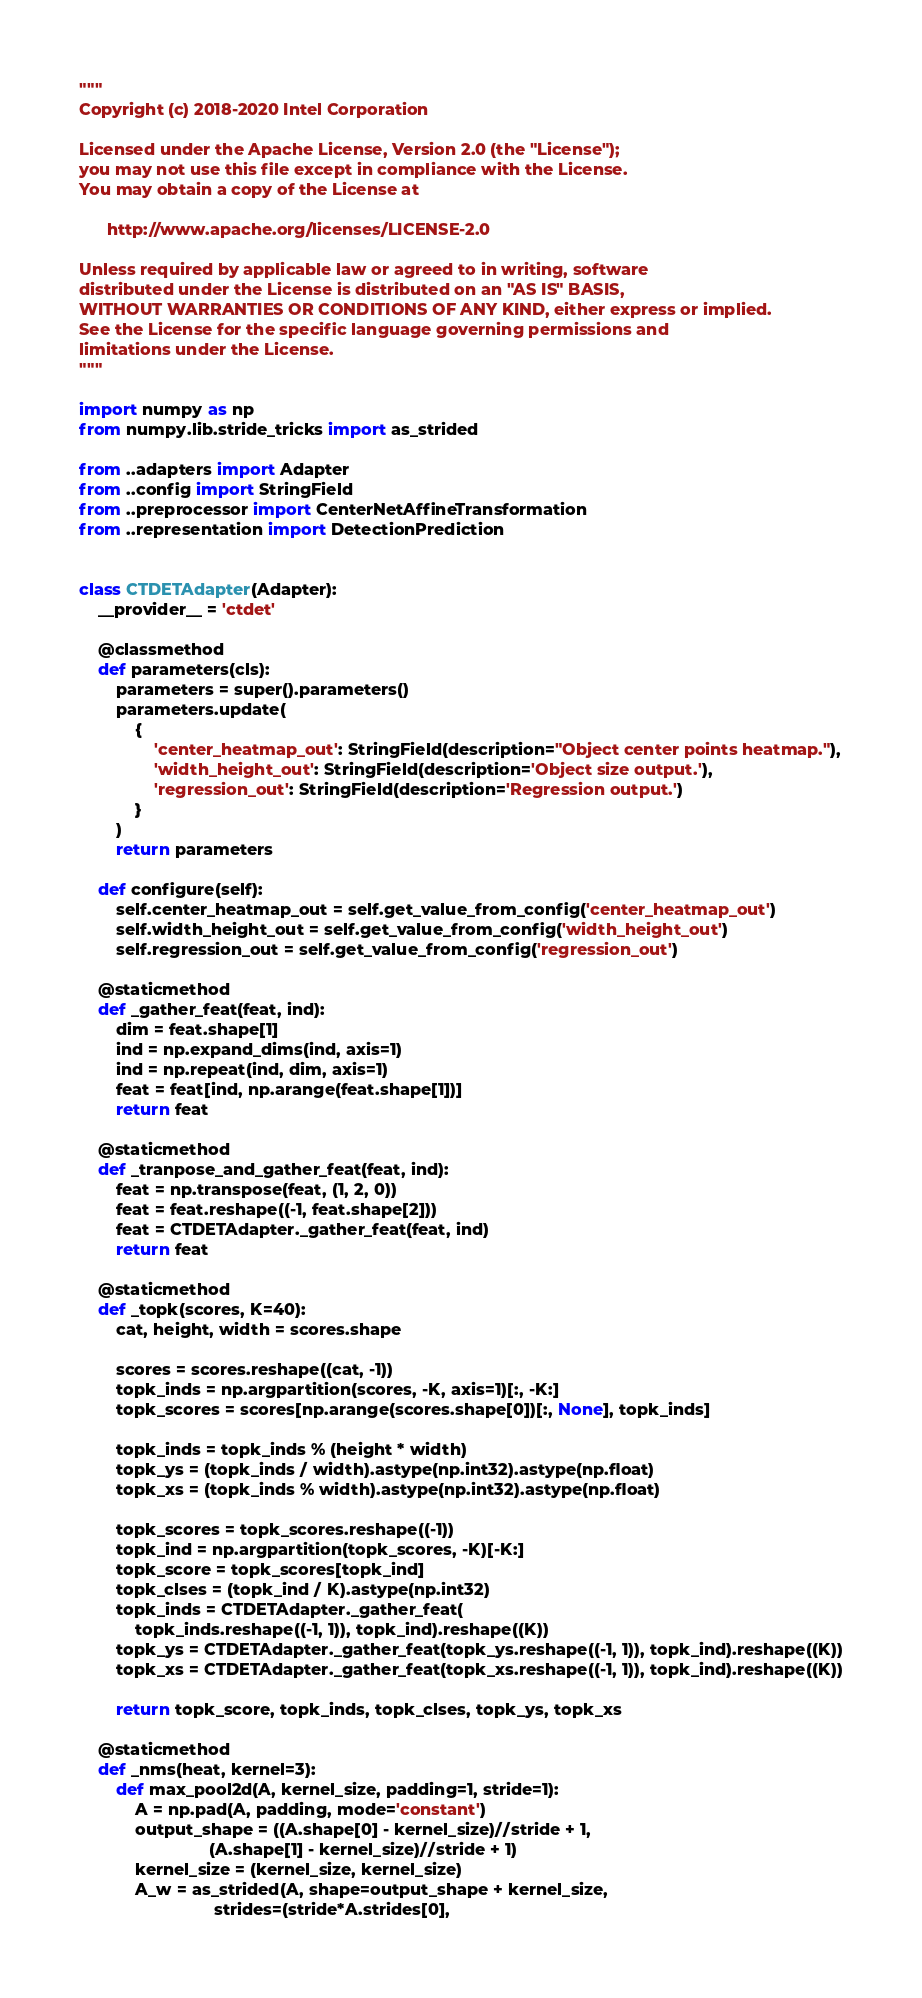Convert code to text. <code><loc_0><loc_0><loc_500><loc_500><_Python_>"""
Copyright (c) 2018-2020 Intel Corporation

Licensed under the Apache License, Version 2.0 (the "License");
you may not use this file except in compliance with the License.
You may obtain a copy of the License at

      http://www.apache.org/licenses/LICENSE-2.0

Unless required by applicable law or agreed to in writing, software
distributed under the License is distributed on an "AS IS" BASIS,
WITHOUT WARRANTIES OR CONDITIONS OF ANY KIND, either express or implied.
See the License for the specific language governing permissions and
limitations under the License.
"""

import numpy as np
from numpy.lib.stride_tricks import as_strided

from ..adapters import Adapter
from ..config import StringField
from ..preprocessor import CenterNetAffineTransformation
from ..representation import DetectionPrediction


class CTDETAdapter(Adapter):
    __provider__ = 'ctdet'

    @classmethod
    def parameters(cls):
        parameters = super().parameters()
        parameters.update(
            {
                'center_heatmap_out': StringField(description="Object center points heatmap."),
                'width_height_out': StringField(description='Object size output.'),
                'regression_out': StringField(description='Regression output.')
            }
        )
        return parameters

    def configure(self):
        self.center_heatmap_out = self.get_value_from_config('center_heatmap_out')
        self.width_height_out = self.get_value_from_config('width_height_out')
        self.regression_out = self.get_value_from_config('regression_out')

    @staticmethod
    def _gather_feat(feat, ind):
        dim = feat.shape[1]
        ind = np.expand_dims(ind, axis=1)
        ind = np.repeat(ind, dim, axis=1)
        feat = feat[ind, np.arange(feat.shape[1])]
        return feat

    @staticmethod
    def _tranpose_and_gather_feat(feat, ind):
        feat = np.transpose(feat, (1, 2, 0))
        feat = feat.reshape((-1, feat.shape[2]))
        feat = CTDETAdapter._gather_feat(feat, ind)
        return feat

    @staticmethod
    def _topk(scores, K=40):
        cat, height, width = scores.shape

        scores = scores.reshape((cat, -1))
        topk_inds = np.argpartition(scores, -K, axis=1)[:, -K:]
        topk_scores = scores[np.arange(scores.shape[0])[:, None], topk_inds]

        topk_inds = topk_inds % (height * width)
        topk_ys = (topk_inds / width).astype(np.int32).astype(np.float)
        topk_xs = (topk_inds % width).astype(np.int32).astype(np.float)

        topk_scores = topk_scores.reshape((-1))
        topk_ind = np.argpartition(topk_scores, -K)[-K:]
        topk_score = topk_scores[topk_ind]
        topk_clses = (topk_ind / K).astype(np.int32)
        topk_inds = CTDETAdapter._gather_feat(
            topk_inds.reshape((-1, 1)), topk_ind).reshape((K))
        topk_ys = CTDETAdapter._gather_feat(topk_ys.reshape((-1, 1)), topk_ind).reshape((K))
        topk_xs = CTDETAdapter._gather_feat(topk_xs.reshape((-1, 1)), topk_ind).reshape((K))

        return topk_score, topk_inds, topk_clses, topk_ys, topk_xs

    @staticmethod
    def _nms(heat, kernel=3):
        def max_pool2d(A, kernel_size, padding=1, stride=1):
            A = np.pad(A, padding, mode='constant')
            output_shape = ((A.shape[0] - kernel_size)//stride + 1,
                            (A.shape[1] - kernel_size)//stride + 1)
            kernel_size = (kernel_size, kernel_size)
            A_w = as_strided(A, shape=output_shape + kernel_size,
                             strides=(stride*A.strides[0],</code> 